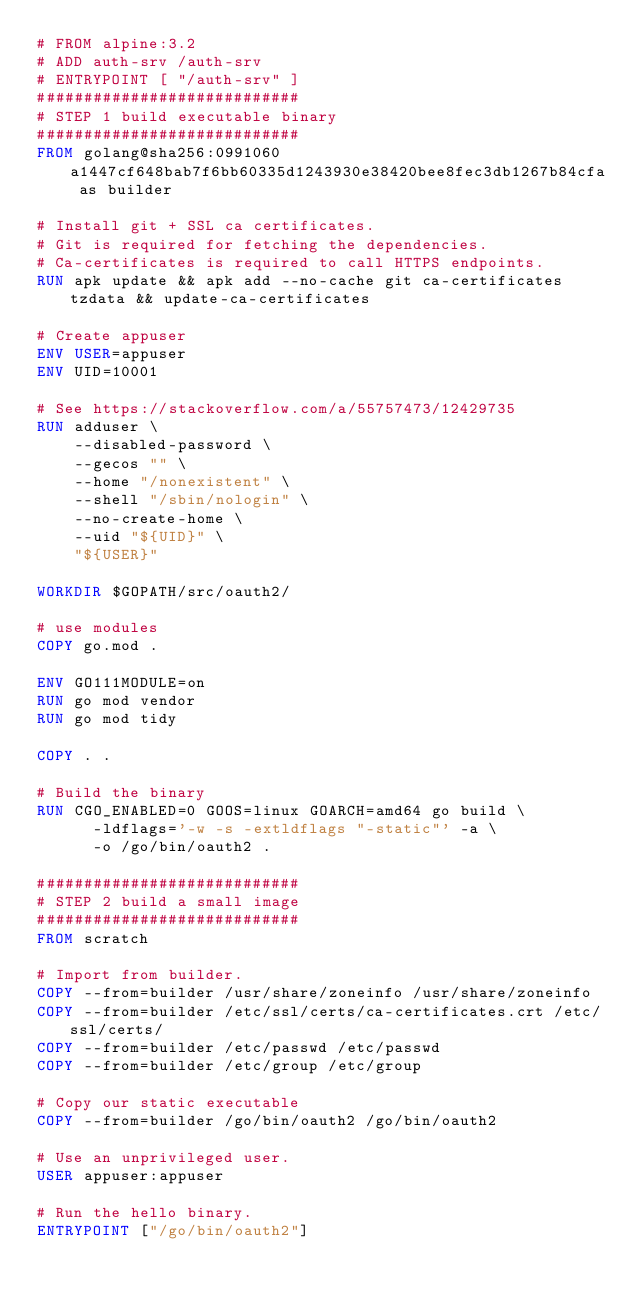Convert code to text. <code><loc_0><loc_0><loc_500><loc_500><_Dockerfile_># FROM alpine:3.2
# ADD auth-srv /auth-srv
# ENTRYPOINT [ "/auth-srv" ]
############################
# STEP 1 build executable binary
############################
FROM golang@sha256:0991060a1447cf648bab7f6bb60335d1243930e38420bee8fec3db1267b84cfa as builder

# Install git + SSL ca certificates.
# Git is required for fetching the dependencies.
# Ca-certificates is required to call HTTPS endpoints.
RUN apk update && apk add --no-cache git ca-certificates tzdata && update-ca-certificates

# Create appuser
ENV USER=appuser
ENV UID=10001

# See https://stackoverflow.com/a/55757473/12429735
RUN adduser \
    --disabled-password \
    --gecos "" \
    --home "/nonexistent" \
    --shell "/sbin/nologin" \
    --no-create-home \
    --uid "${UID}" \
    "${USER}"

WORKDIR $GOPATH/src/oauth2/

# use modules
COPY go.mod .

ENV GO111MODULE=on
RUN go mod vendor
RUN go mod tidy

COPY . .

# Build the binary
RUN CGO_ENABLED=0 GOOS=linux GOARCH=amd64 go build \
      -ldflags='-w -s -extldflags "-static"' -a \
      -o /go/bin/oauth2 .

############################
# STEP 2 build a small image
############################
FROM scratch

# Import from builder.
COPY --from=builder /usr/share/zoneinfo /usr/share/zoneinfo
COPY --from=builder /etc/ssl/certs/ca-certificates.crt /etc/ssl/certs/
COPY --from=builder /etc/passwd /etc/passwd
COPY --from=builder /etc/group /etc/group

# Copy our static executable
COPY --from=builder /go/bin/oauth2 /go/bin/oauth2

# Use an unprivileged user.
USER appuser:appuser

# Run the hello binary.
ENTRYPOINT ["/go/bin/oauth2"]
</code> 